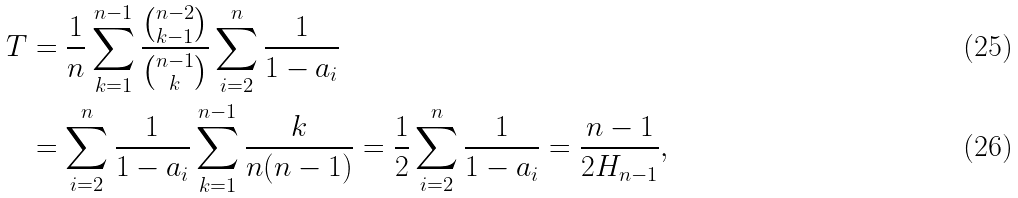Convert formula to latex. <formula><loc_0><loc_0><loc_500><loc_500>T & = \frac { 1 } { n } \sum _ { k = 1 } ^ { n - 1 } \frac { \binom { n - 2 } { k - 1 } } { \binom { n - 1 } { k } } \sum _ { i = 2 } ^ { n } \frac { 1 } { 1 - a _ { i } } \\ & = \sum _ { i = 2 } ^ { n } \frac { 1 } { 1 - a _ { i } } \sum _ { k = 1 } ^ { n - 1 } \frac { k } { n ( n - 1 ) } = \frac { 1 } { 2 } \sum _ { i = 2 } ^ { n } \frac { 1 } { 1 - a _ { i } } = \frac { n - 1 } { 2 H _ { n - 1 } } ,</formula> 